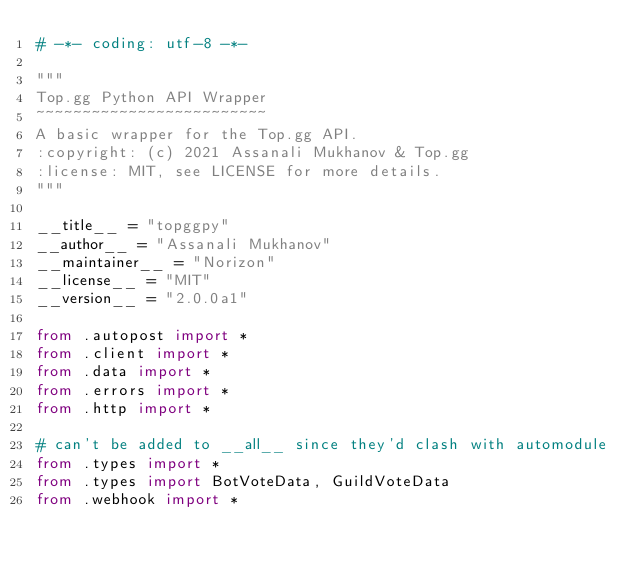Convert code to text. <code><loc_0><loc_0><loc_500><loc_500><_Python_># -*- coding: utf-8 -*-

"""
Top.gg Python API Wrapper
~~~~~~~~~~~~~~~~~~~~~~~~~
A basic wrapper for the Top.gg API.
:copyright: (c) 2021 Assanali Mukhanov & Top.gg
:license: MIT, see LICENSE for more details.
"""

__title__ = "topggpy"
__author__ = "Assanali Mukhanov"
__maintainer__ = "Norizon"
__license__ = "MIT"
__version__ = "2.0.0a1"

from .autopost import *
from .client import *
from .data import *
from .errors import *
from .http import *

# can't be added to __all__ since they'd clash with automodule
from .types import *
from .types import BotVoteData, GuildVoteData
from .webhook import *
</code> 